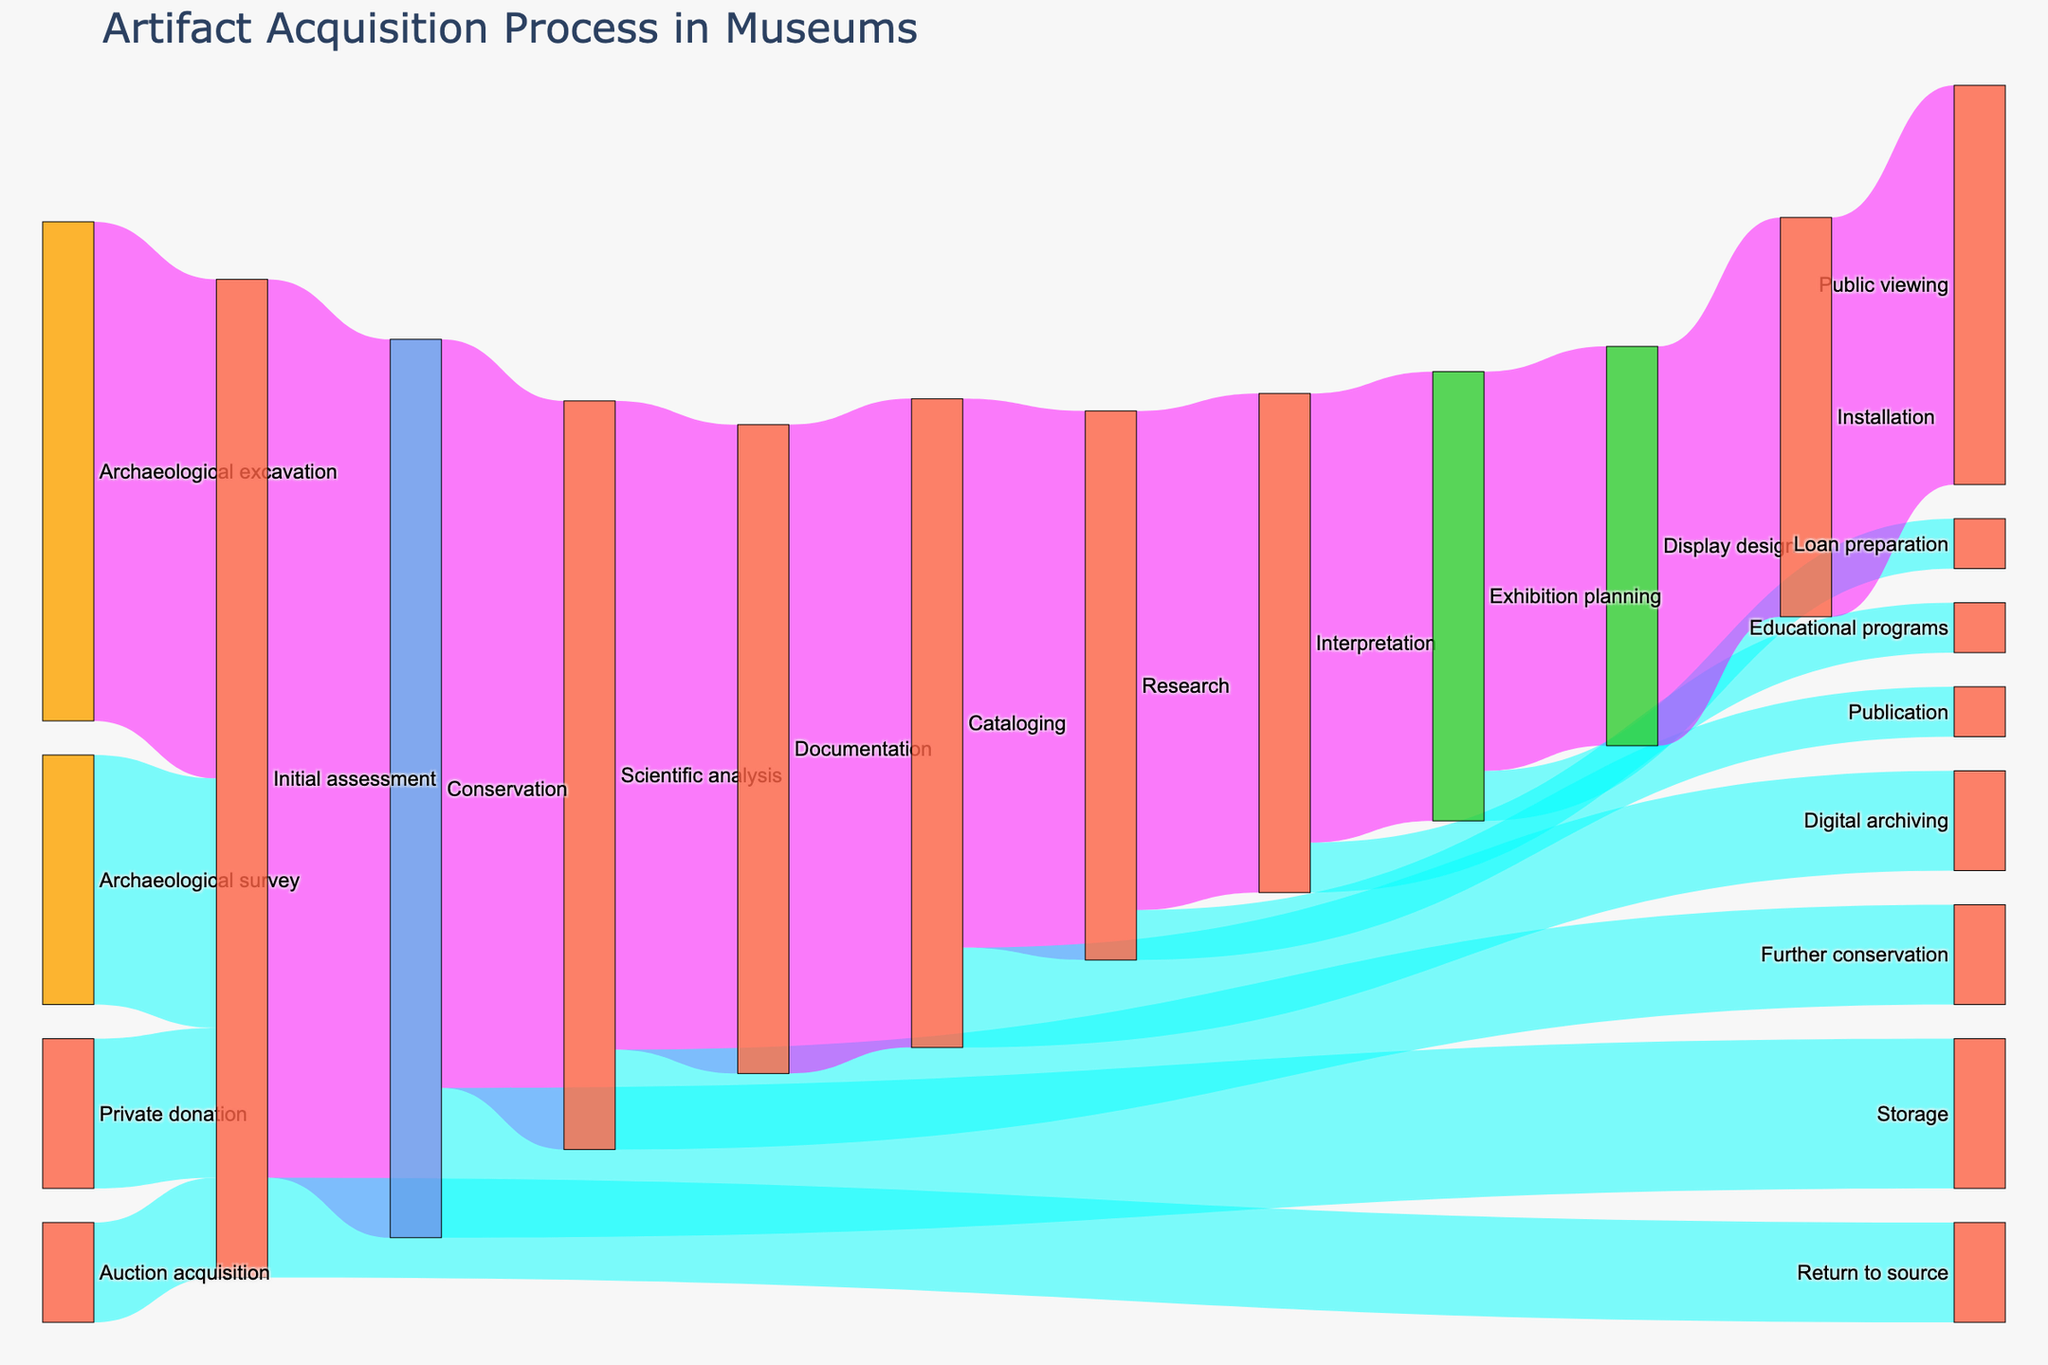What is the title of the Sankey diagram? The title of the Sankey diagram is usually displayed at the top of the figure in larger and bold font to make it stand out. Observing the top of the plot, you can read the title assigned to it.
Answer: Artifact Acquisition Process in Museums How many sources contribute artifacts to the Initial assessment? To determine the number of sources contributing to Initial assessment, we check the leftmost side of the Sankey diagram and count the different incoming flows that lead to Initial assessment. These flows originate from Archaeological excavation, Archaeological survey, Private donation, and Auction acquisition.
Answer: 4 Which step follows after Installation? To identify the step that follows Installation, trace the directional flow from the Installation node. Since Sankey diagrams use arrows to indicate flow direction, follow the arrow leading out of Installation to find the connected target.
Answer: Public viewing What is the combined total of artifacts received from Archaeological excavation and Archaeological survey? Sum the values corresponding to the flows originating from Archaeological excavation and Archaeological survey, both directed towards Initial assessment. This involves adding 100 (from Archaeological excavation) and 50 (from Archaeological survey).
Answer: 150 Which process has more artifacts going through it: Digital archiving or Loan preparation? Compare the values at the nodes for Digital archiving and Loan preparation. These are the numbers directly beside their respective flows. Digital archiving shows a flow of 20, whereas Loan preparation shows a flow of 10.
Answer: Digital archiving Is the flow from Exhibition planning to Display design greater than the flow from Research to Educational programs? Examine the value labels for both flows: Exhibition planning to Display design and Research to Educational programs. Compare the two values to determine which is larger.
Answer: Yes What is the final destination of the artifacts after Exhibition planning? Trace the paths originating from Exhibition planning and see where the flows culminate. The final steps from Exhibition planning lead to both Display design and Loan preparation. Observing further from Display design, the flow ends at Installation and Public viewing.
Answer: Public viewing How many artifacts are returned to the source after Initial assessment? Find the Initial assessment node and follow the flow labeled "Return to source." The corresponding flow value represents the number of artifacts returned to the source.
Answer: 20 